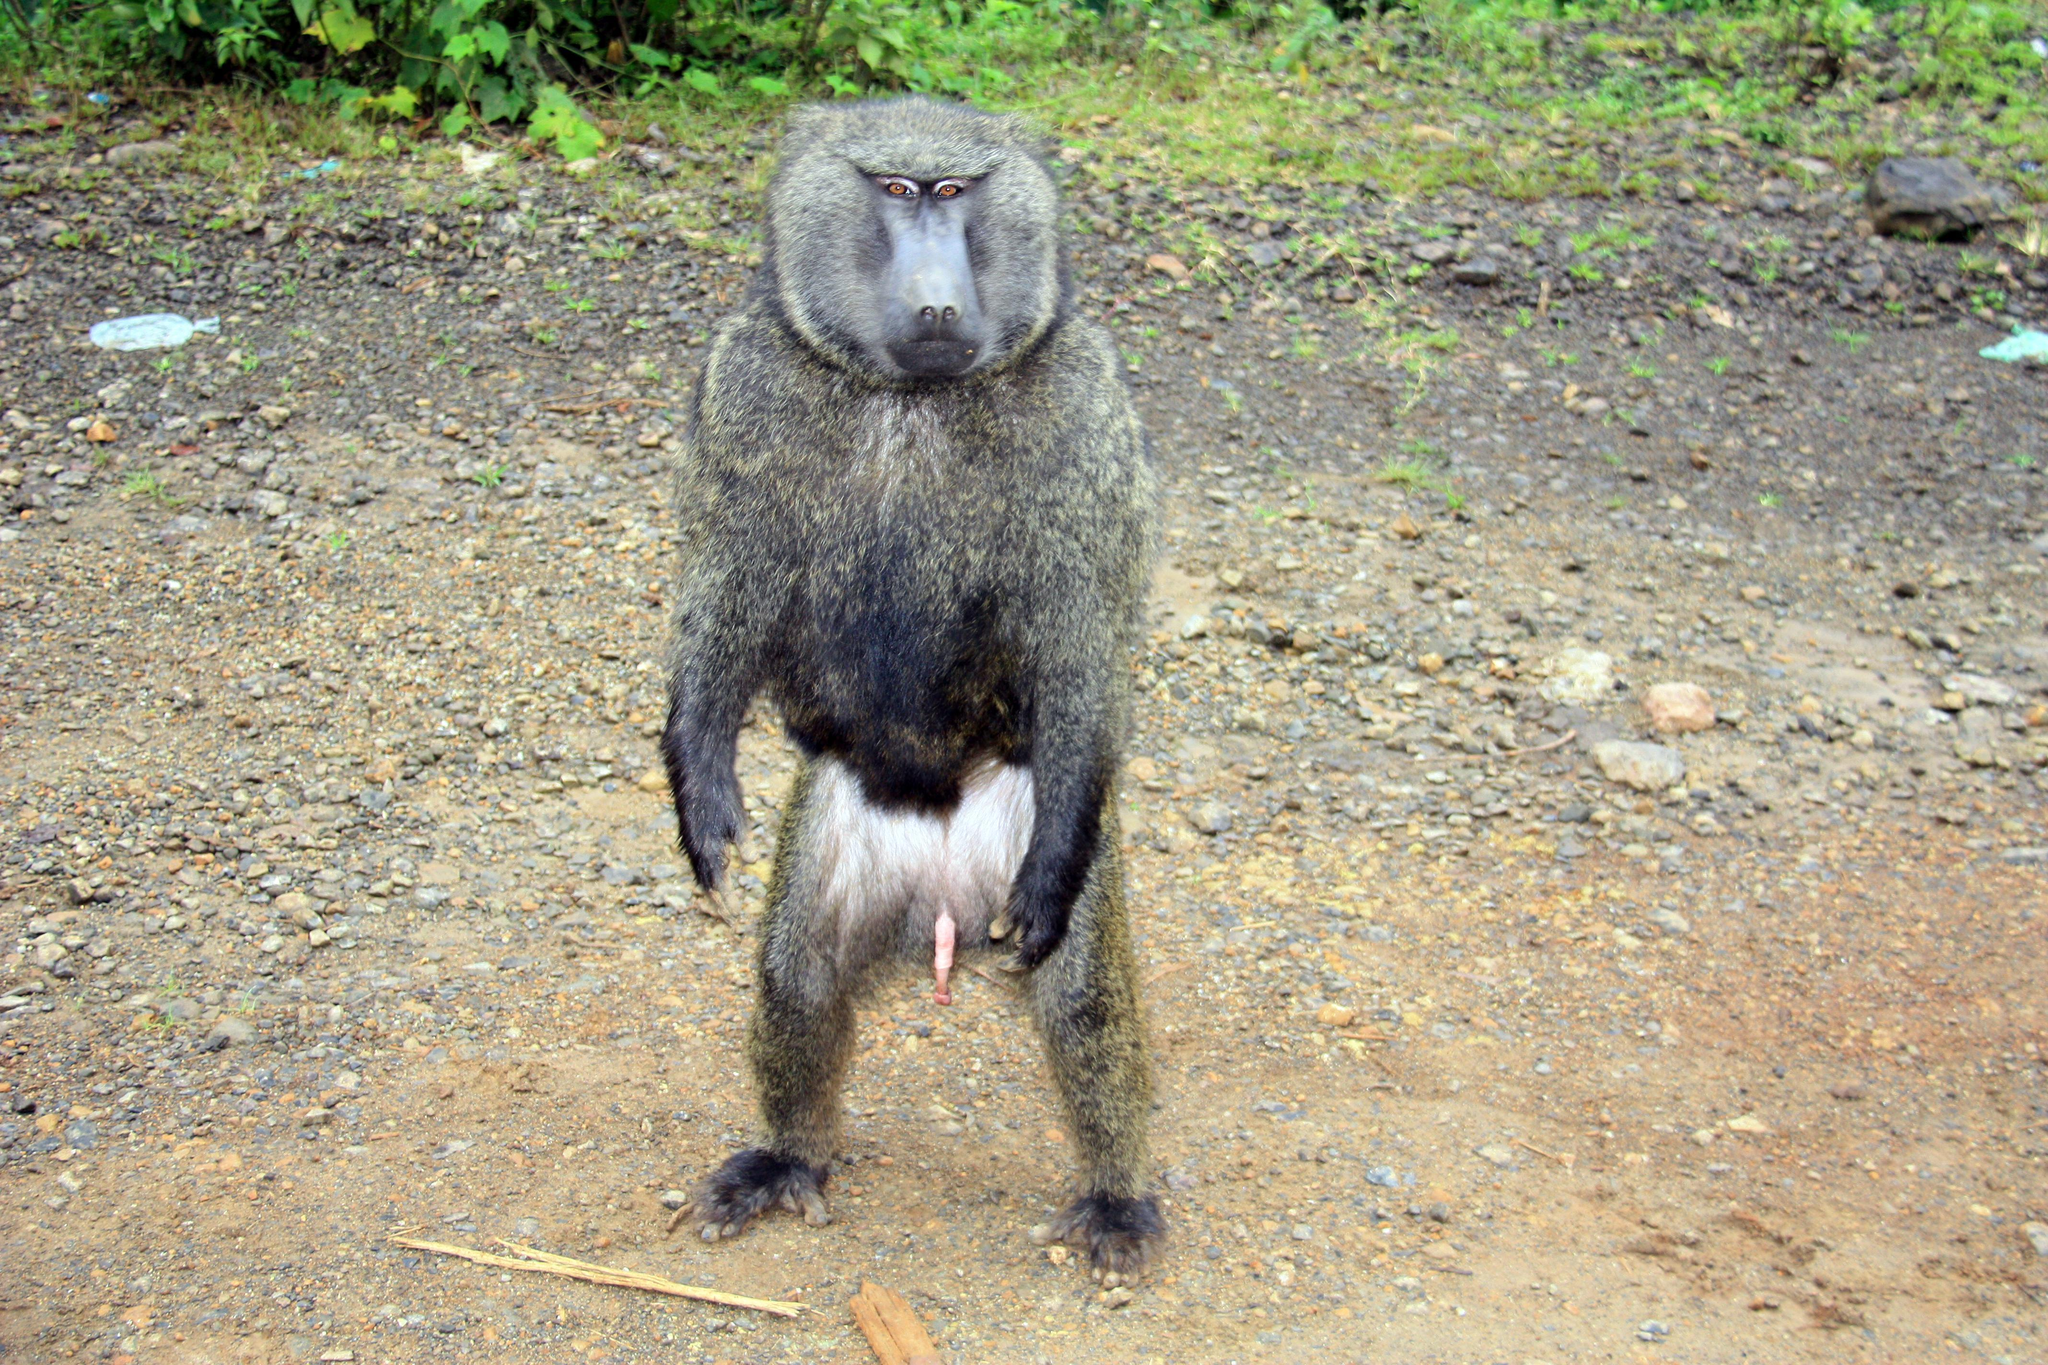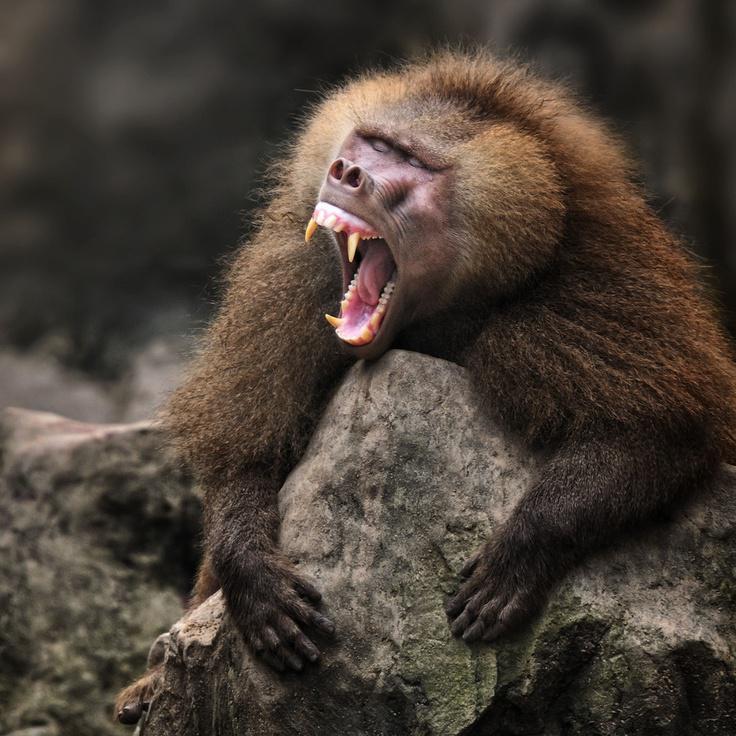The first image is the image on the left, the second image is the image on the right. Considering the images on both sides, is "There are at most two baboons." valid? Answer yes or no. Yes. The first image is the image on the left, the second image is the image on the right. Evaluate the accuracy of this statement regarding the images: "There are at most two baboons.". Is it true? Answer yes or no. Yes. 